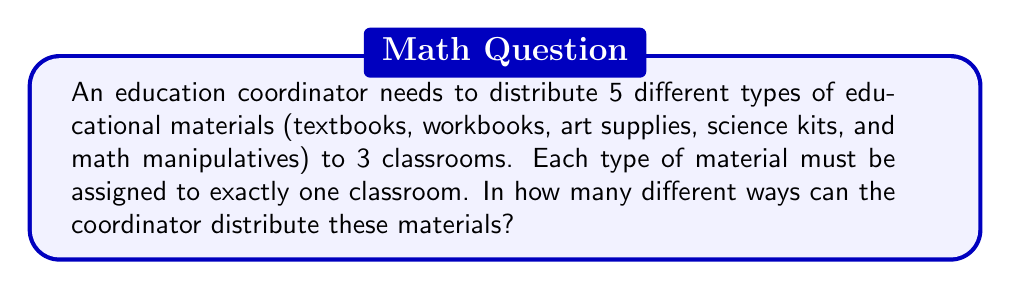Help me with this question. Let's approach this step-by-step:

1) We have 5 different types of materials, and each type must be assigned to one of 3 classrooms.

2) This is a classic example of the Multiplication Principle in combinatorics.

3) For each type of material:
   - We have 3 choices (classrooms) to assign it to.

4) Since we're making this choice independently for each of the 5 types of materials, we multiply the number of choices for each decision:

   $$ 3 \times 3 \times 3 \times 3 \times 3 $$

5) This can be written as an exponent:

   $$ 3^5 $$

6) To calculate this:
   $$ 3^5 = 3 \times 3 \times 3 \times 3 \times 3 = 243 $$

Therefore, there are 243 different ways to distribute the 5 types of educational materials to the 3 classrooms.
Answer: 243 